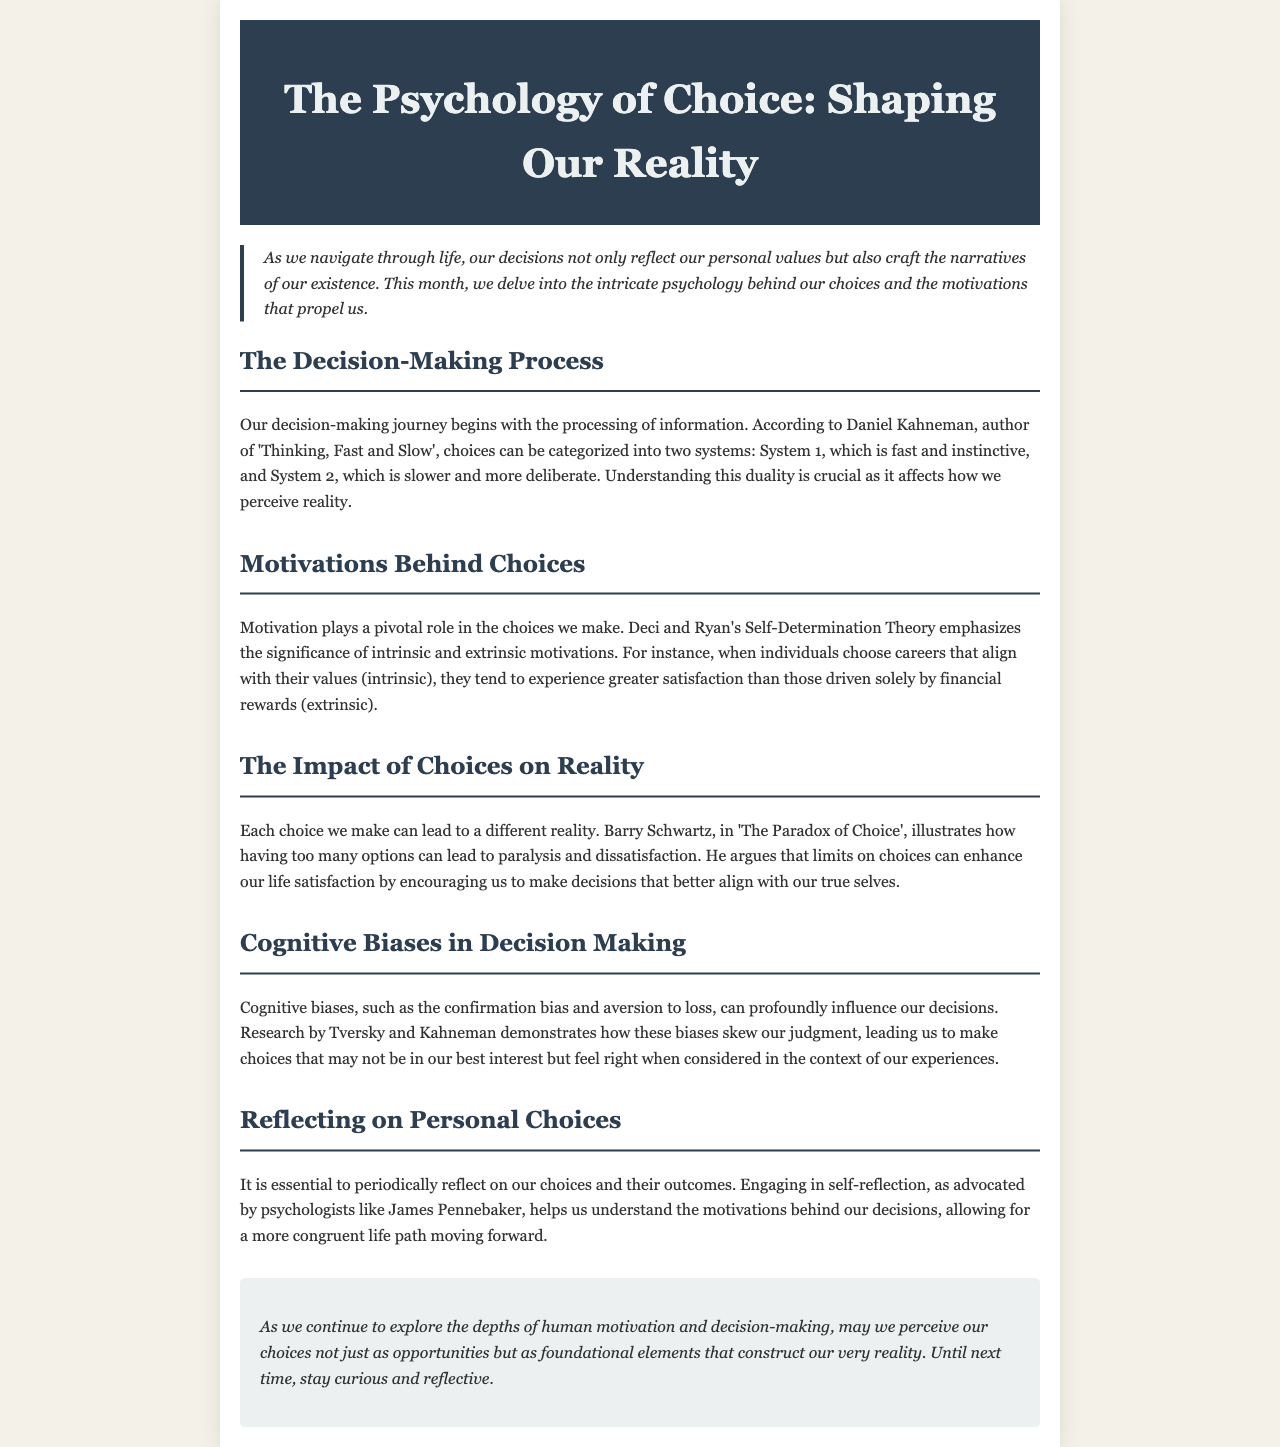What is the title of the newsletter? The title is stated in the header of the document.
Answer: The Psychology of Choice: Shaping Our Reality Who is the author of 'Thinking, Fast and Slow'? The document mentions Daniel Kahneman as the author of this influential book.
Answer: Daniel Kahneman What theory emphasizes intrinsic and extrinsic motivations? The theory that highlights these types of motivations is referenced in the section on motivations behind choices.
Answer: Self-Determination Theory Which book discusses the paradox of choice? The specific book that addresses this theme is mentioned in the impact choices section.
Answer: The Paradox of Choice What psychological process helps understand motivations behind decisions? The referenced psychological process encourages self-examination of past decisions.
Answer: Self-reflection According to the document, what can too many choices lead to? The document indicates that having excessive options can result in a specific negative outcome.
Answer: Paralysis and dissatisfaction Who conducted research demonstrating the influence of cognitive biases? The section on cognitive biases names two researchers related to this topic.
Answer: Tversky and Kahneman What should we periodically reflect on, as mentioned in the newsletter? The conclusion emphasizes the importance of reflecting on a specific aspect of our lives.
Answer: Our choices and their outcomes What phrase describes the overarching theme of the newsletter? The introduction encapsulates the broad theme discussed throughout the newsletter.
Answer: Human motivation and decision-making 